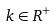<formula> <loc_0><loc_0><loc_500><loc_500>k \in R ^ { + }</formula> 